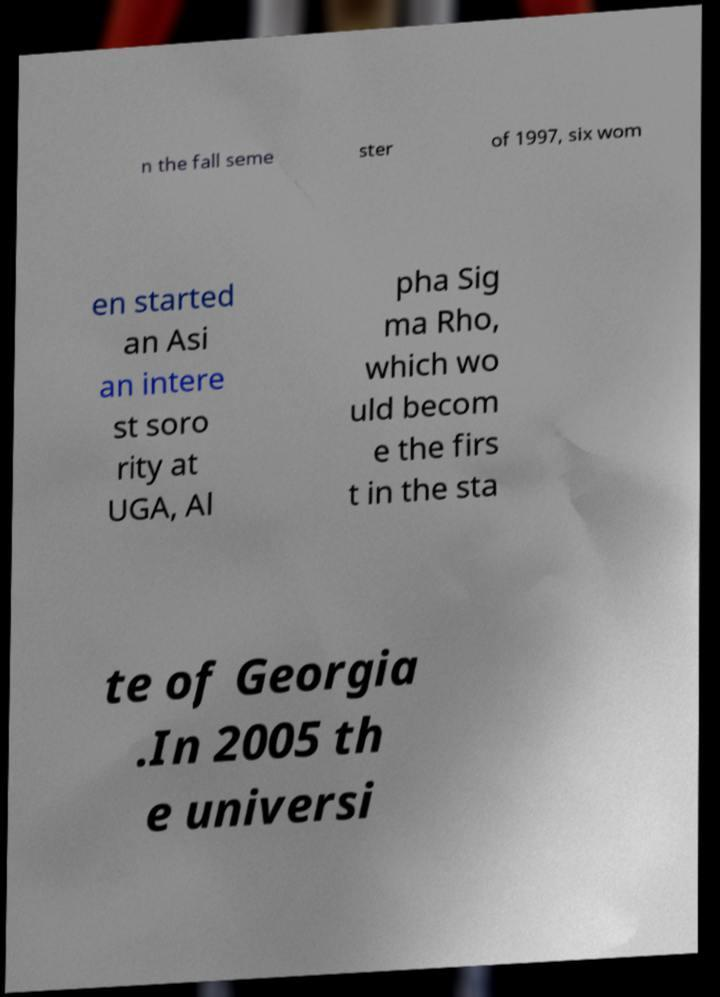For documentation purposes, I need the text within this image transcribed. Could you provide that? n the fall seme ster of 1997, six wom en started an Asi an intere st soro rity at UGA, Al pha Sig ma Rho, which wo uld becom e the firs t in the sta te of Georgia .In 2005 th e universi 